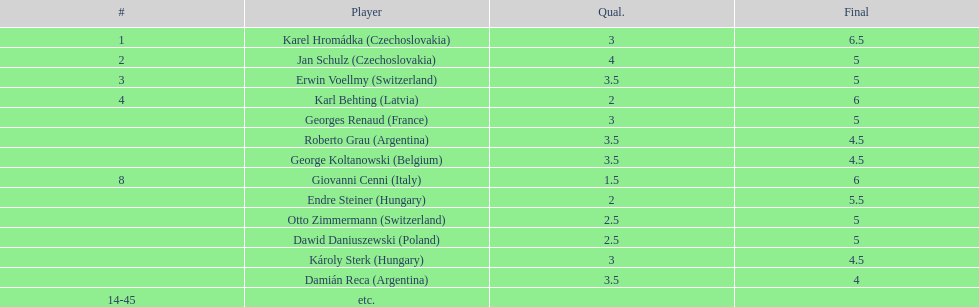How many players tied for 4th place? 4. 